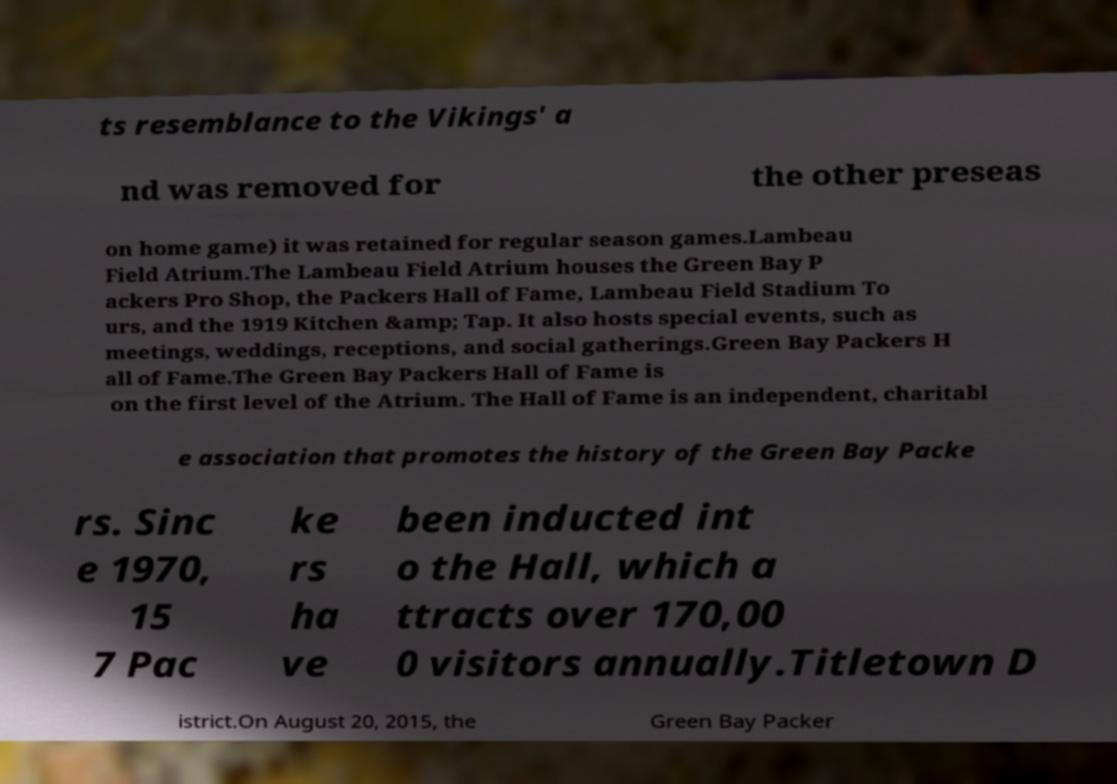Can you read and provide the text displayed in the image?This photo seems to have some interesting text. Can you extract and type it out for me? ts resemblance to the Vikings' a nd was removed for the other preseas on home game) it was retained for regular season games.Lambeau Field Atrium.The Lambeau Field Atrium houses the Green Bay P ackers Pro Shop, the Packers Hall of Fame, Lambeau Field Stadium To urs, and the 1919 Kitchen &amp; Tap. It also hosts special events, such as meetings, weddings, receptions, and social gatherings.Green Bay Packers H all of Fame.The Green Bay Packers Hall of Fame is on the first level of the Atrium. The Hall of Fame is an independent, charitabl e association that promotes the history of the Green Bay Packe rs. Sinc e 1970, 15 7 Pac ke rs ha ve been inducted int o the Hall, which a ttracts over 170,00 0 visitors annually.Titletown D istrict.On August 20, 2015, the Green Bay Packer 